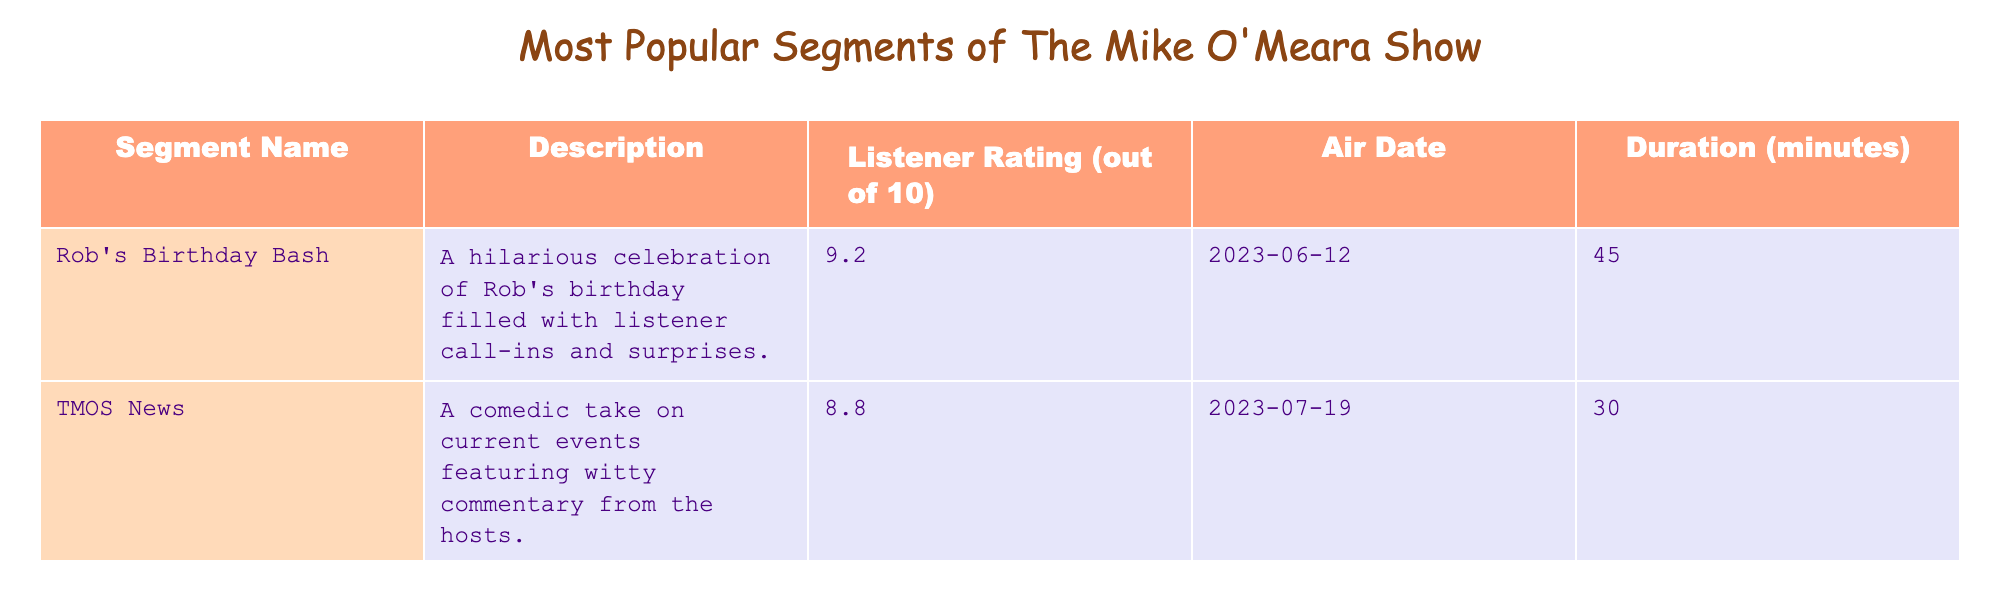What is the listener rating of "Rob's Birthday Bash"? The table shows the "Listener Rating" column, and for "Rob's Birthday Bash," the rating is 9.2.
Answer: 9.2 Which segment has the longest duration? By comparing the "Duration" column, "Rob's Birthday Bash" has the longest duration at 45 minutes.
Answer: "Rob's Birthday Bash" Is the listener rating of "Matt's Movie Reviews" higher than 8.5? The listener rating of "Matt's Movie Reviews" is 9.0, which is indeed higher than 8.5.
Answer: Yes What is the average listener rating of the segments listed? To find the average, add up the ratings (9.2 + 8.8 + 9.0 = 27), then divide by the number of segments (3). The average is 27/3 = 9.0.
Answer: 9.0 Which segment aired on the latest date? The "Air Date" column shows that "Matt's Movie Reviews" aired on 2023-08-05, which is the latest date among the segments listed.
Answer: "Matt's Movie Reviews" Does any segment have a listener rating of exactly 9.0? Yes, the listener rating for "Matt's Movie Reviews" is exactly 9.0.
Answer: Yes What is the difference in listener ratings between "TMOS News" and "Matt's Movie Reviews"? "TMOS News" has a rating of 8.8 and "Matt's Movie Reviews" has 9.0. The difference is 9.0 - 8.8 = 0.2.
Answer: 0.2 How many segments have a listener rating of 9.0 or higher? The segments with ratings of 9.0 or higher are "Rob's Birthday Bash" (9.2) and "Matt's Movie Reviews" (9.0), making a total of 2 segments.
Answer: 2 What proportion of the segments have a duration of less than 30 minutes? "TMOS News" (30 minutes) is the only segment close to 30 minutes, while "Matt's Movie Reviews" (25 minutes) has a duration less than 30. Since there are 3 segments, the proportion is 1/3.
Answer: 1/3 